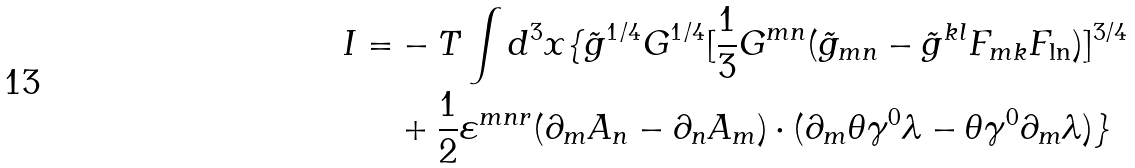<formula> <loc_0><loc_0><loc_500><loc_500>I = & - T \int { d ^ { 3 } x \{ } \tilde { g } ^ { 1 / 4 } G ^ { 1 / 4 } [ \frac { 1 } { 3 } G ^ { m n } ( \tilde { g } _ { m n } - \tilde { g } ^ { k l } F _ { m k } F _ { \ln } ) ] ^ { 3 / 4 } \\ & + \frac { 1 } { 2 } \varepsilon ^ { m n r } ( \partial _ { m } A _ { n } - \partial _ { n } A _ { m } ) \cdot ( \partial _ { m } \theta \gamma ^ { 0 } \lambda - \theta \gamma ^ { 0 } \partial _ { m } \lambda ) \}</formula> 